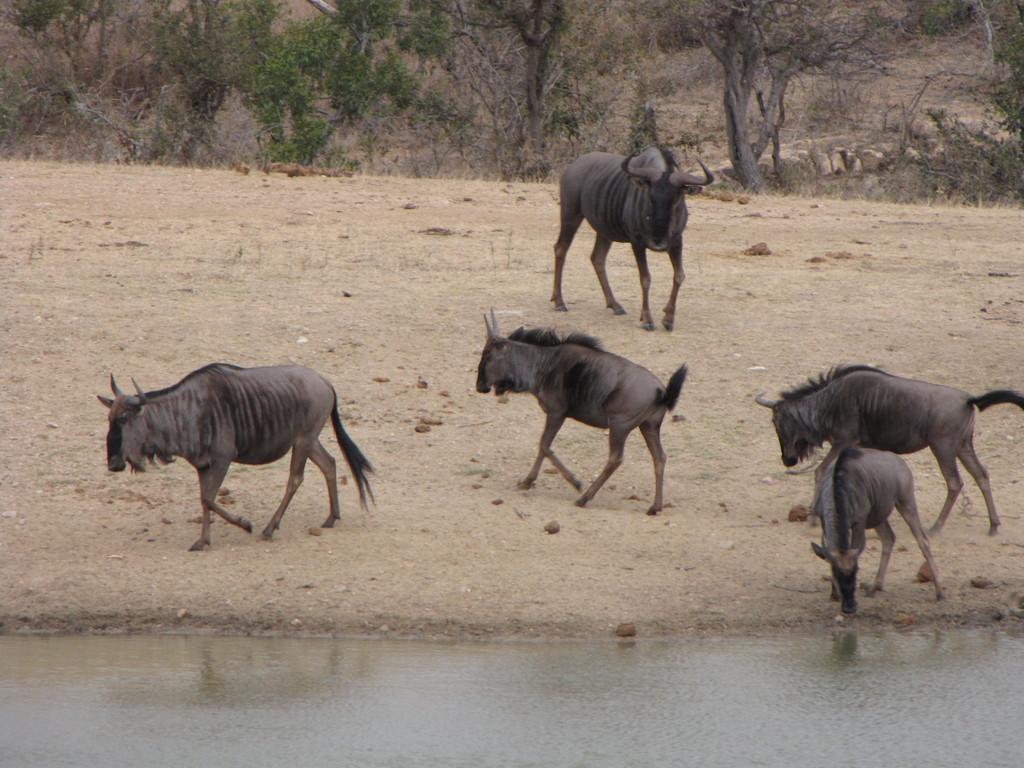Could you give a brief overview of what you see in this image? In this image, we can see some animals and there is water, in the background there are some trees. 